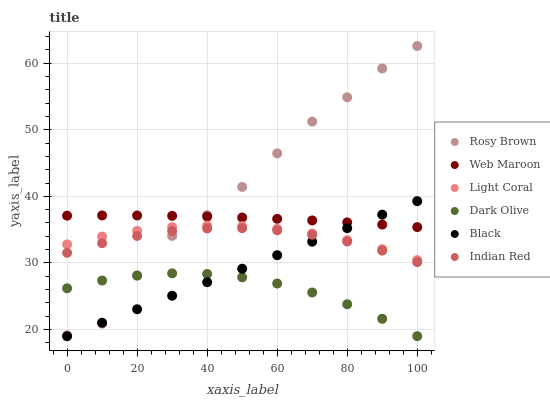Does Dark Olive have the minimum area under the curve?
Answer yes or no. Yes. Does Rosy Brown have the maximum area under the curve?
Answer yes or no. Yes. Does Web Maroon have the minimum area under the curve?
Answer yes or no. No. Does Web Maroon have the maximum area under the curve?
Answer yes or no. No. Is Black the smoothest?
Answer yes or no. Yes. Is Rosy Brown the roughest?
Answer yes or no. Yes. Is Dark Olive the smoothest?
Answer yes or no. No. Is Dark Olive the roughest?
Answer yes or no. No. Does Black have the lowest value?
Answer yes or no. Yes. Does Dark Olive have the lowest value?
Answer yes or no. No. Does Rosy Brown have the highest value?
Answer yes or no. Yes. Does Web Maroon have the highest value?
Answer yes or no. No. Is Indian Red less than Web Maroon?
Answer yes or no. Yes. Is Light Coral greater than Dark Olive?
Answer yes or no. Yes. Does Black intersect Light Coral?
Answer yes or no. Yes. Is Black less than Light Coral?
Answer yes or no. No. Is Black greater than Light Coral?
Answer yes or no. No. Does Indian Red intersect Web Maroon?
Answer yes or no. No. 